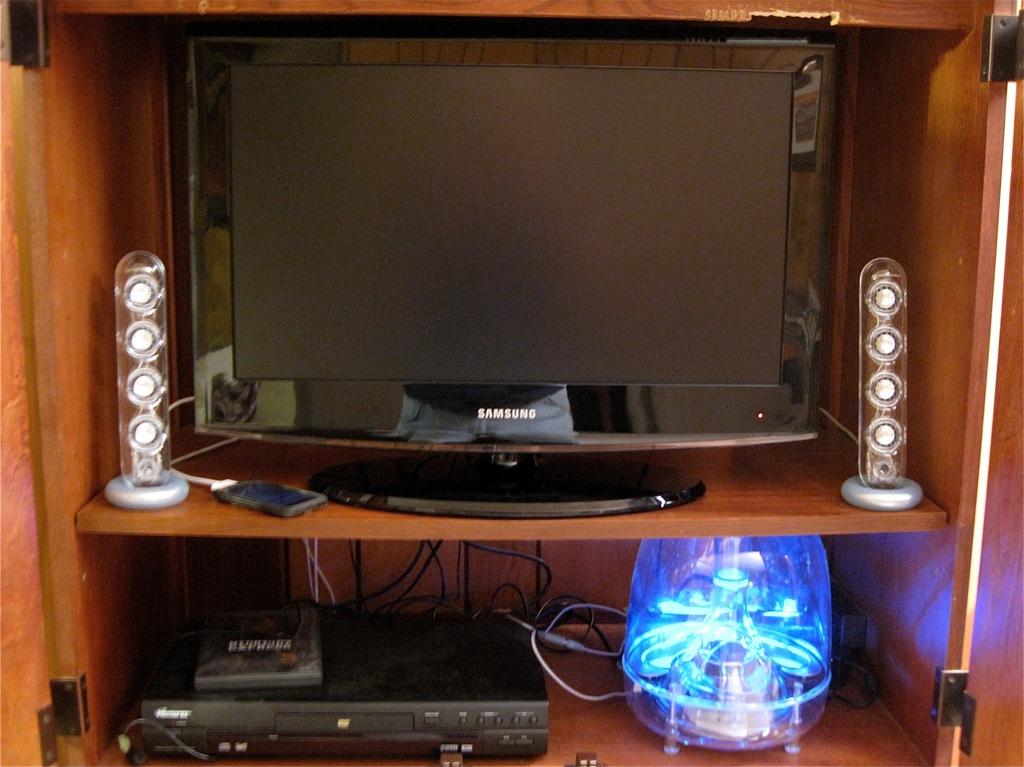Which brand of tv?
Offer a terse response. Samsung. 